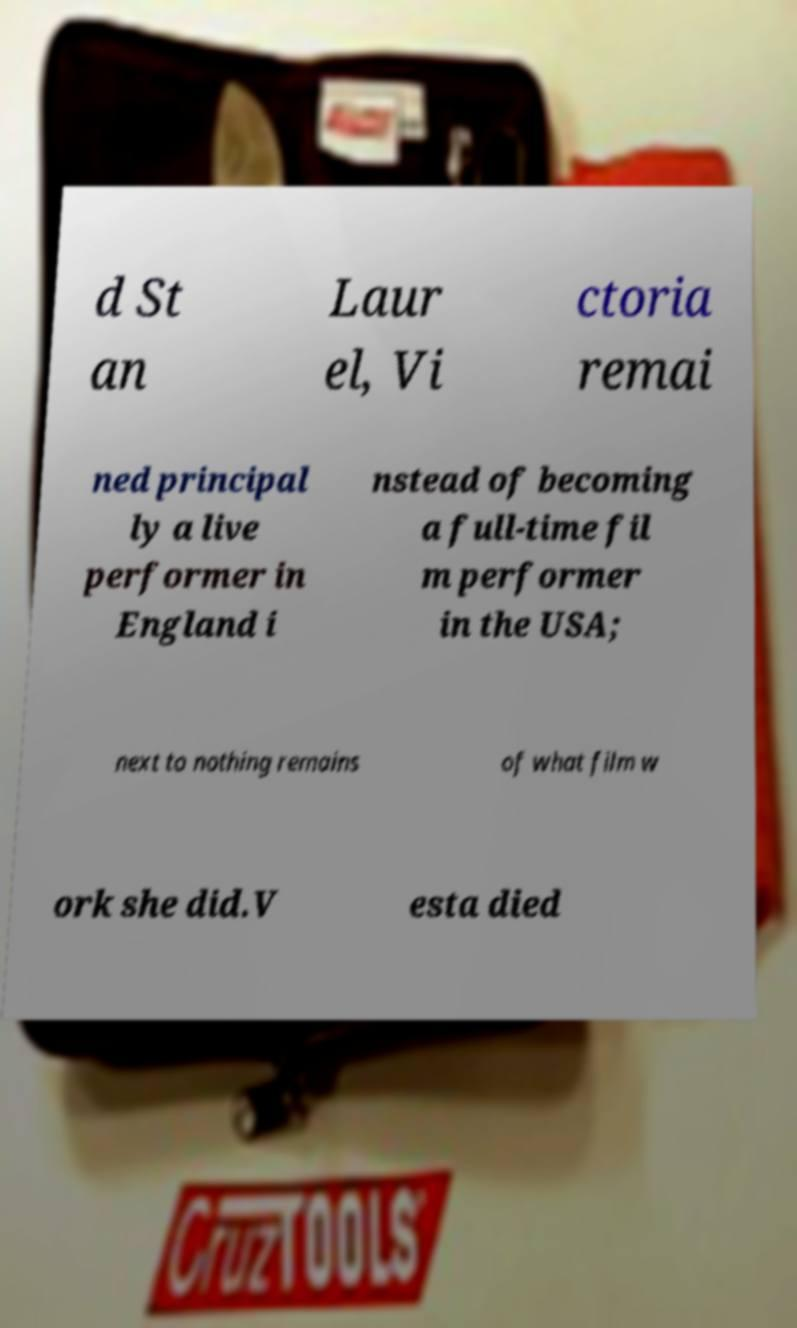Can you accurately transcribe the text from the provided image for me? d St an Laur el, Vi ctoria remai ned principal ly a live performer in England i nstead of becoming a full-time fil m performer in the USA; next to nothing remains of what film w ork she did.V esta died 